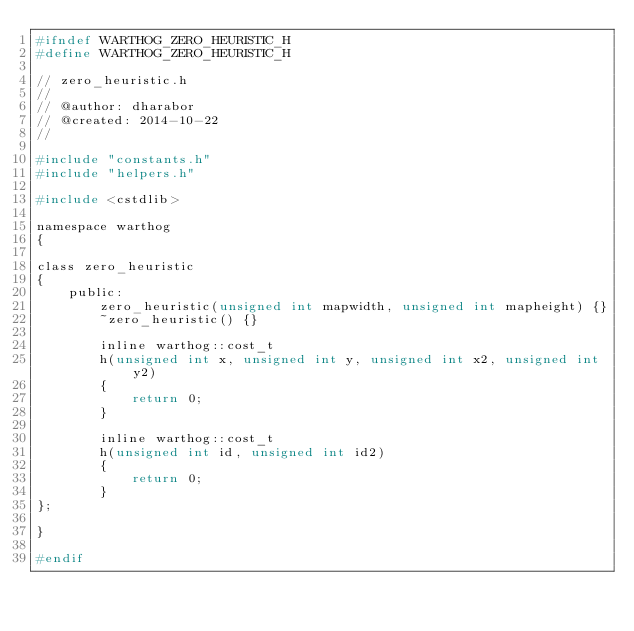<code> <loc_0><loc_0><loc_500><loc_500><_C_>#ifndef WARTHOG_ZERO_HEURISTIC_H
#define WARTHOG_ZERO_HEURISTIC_H

// zero_heuristic.h
//
// @author: dharabor
// @created: 2014-10-22
//

#include "constants.h"
#include "helpers.h"

#include <cstdlib>

namespace warthog
{

class zero_heuristic
{
	public:
		zero_heuristic(unsigned int mapwidth, unsigned int mapheight) {}
		~zero_heuristic() {}

		inline warthog::cost_t
		h(unsigned int x, unsigned int y, unsigned int x2, unsigned int y2)
		{
            return 0;
		}

		inline warthog::cost_t
		h(unsigned int id, unsigned int id2)
		{
            return 0;
		}
};

}

#endif

</code> 